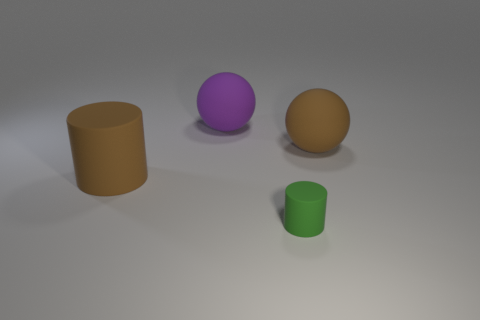Add 4 red cylinders. How many objects exist? 8 Add 2 brown spheres. How many brown spheres are left? 3 Add 2 tiny blue metal things. How many tiny blue metal things exist? 2 Subtract 0 yellow spheres. How many objects are left? 4 Subtract all gray blocks. Subtract all big brown matte cylinders. How many objects are left? 3 